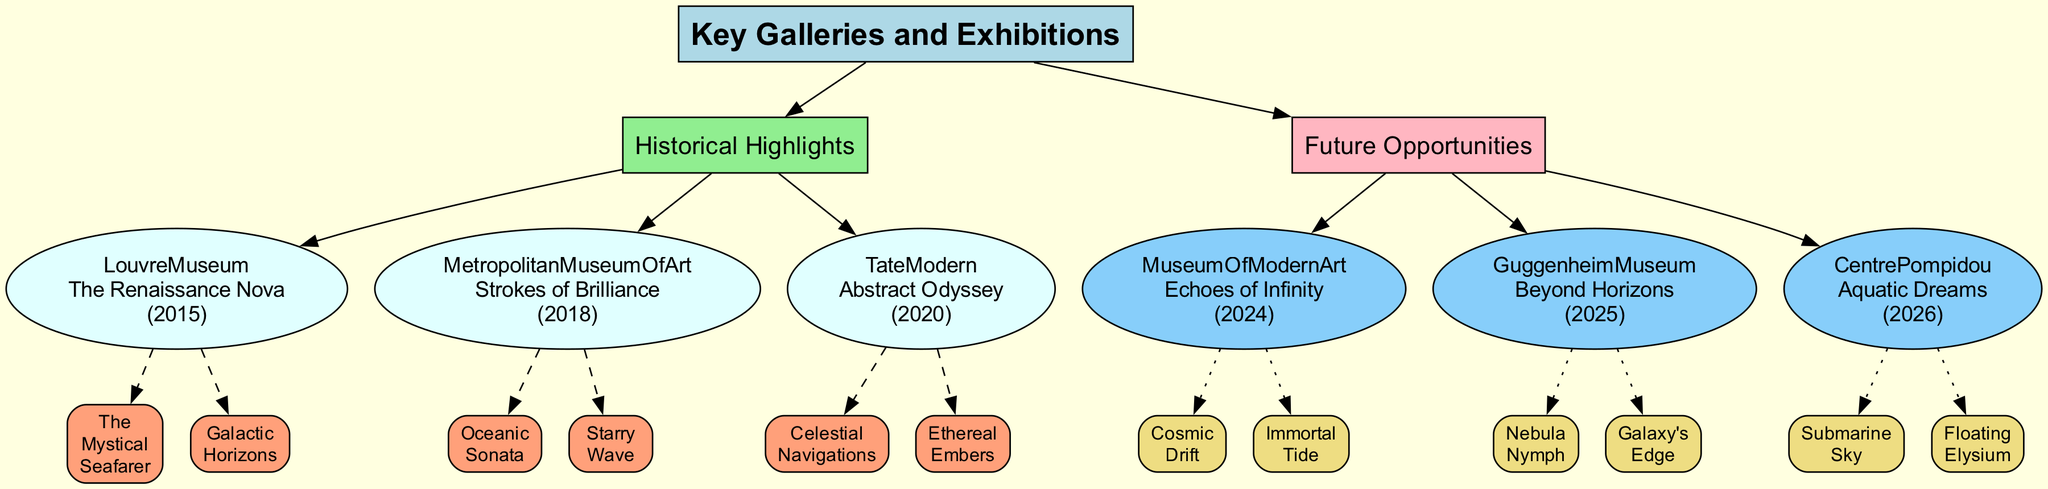What is the name of the exhibition held at the Louvre Museum? The exhibition name associated with the Louvre Museum node in the diagram is "The Renaissance Nova".
Answer: The Renaissance Nova In which year did the Tate Modern showcase a Captain's exhibition? The diagram indicates that the exhibition at Tate Modern occurred in 2020, as shown near the corresponding node.
Answer: 2020 How many notable works are presented in the "Strokes of Brilliance" exhibition? By examining the diagram, I can see the connection from the Metropolitan Museum of Art node to two notable works, which are listed as part of that exhibition.
Answer: 2 What potential works are associated with the "Echoes of Infinity" exhibition planned for 2024? The diagram specifies "Cosmic Drift" and "Immortal Tide" as the potential works linked to the Museum of Modern Art's exhibition node.
Answer: Cosmic Drift, Immortal Tide Which future exhibition features the work "Nebula Nymph"? By looking at the diagram, "Nebula Nymph" is listed under the "Beyond Horizons" exhibition which is connected to the Guggenheim Museum node.
Answer: Beyond Horizons What is the main theme of the "Abstract Odyssey" exhibition? The theme can be inferred from the notable works associated with the Tate Modern node: "Celestial Navigations" and "Ethereal Embers", suggesting an abstract or celestial focus.
Answer: Abstract Odyssey Which gallery features the exhibition with the earliest planned year? The diagram shows that the Museum of Modern Art's exhibition "Echoes of Infinity" is scheduled for 2024, which is the earliest among the future opportunities listed.
Answer: Museum of Modern Art How many galleries are listed under Historical Highlights? Counting from the diagram, there are three galleries shown under the Historical Highlights section: Louvre Museum, Metropolitan Museum of Art, and Tate Modern.
Answer: 3 What color represents future opportunities in the diagram? The color associated with the Future Opportunities section of the diagram is light pink, as indicated in the attributes of that node.
Answer: Light pink 